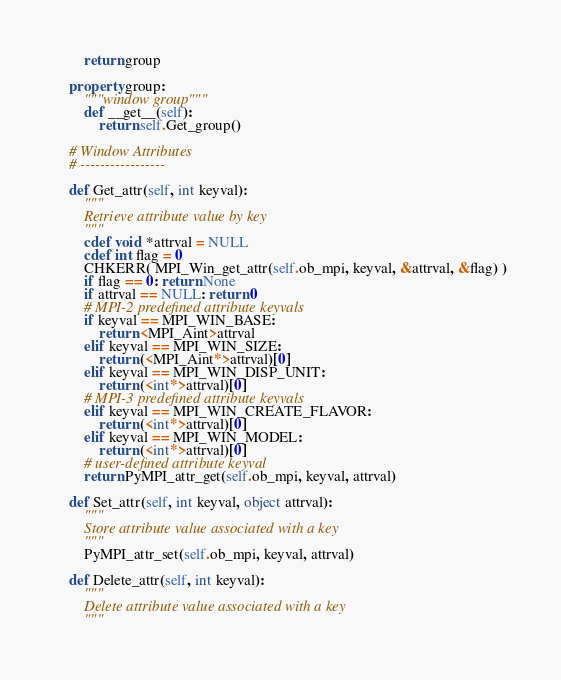Convert code to text. <code><loc_0><loc_0><loc_500><loc_500><_Cython_>        return group

    property group:
        """window group"""
        def __get__(self):
            return self.Get_group()

    # Window Attributes
    # -----------------

    def Get_attr(self, int keyval):
        """
        Retrieve attribute value by key
        """
        cdef void *attrval = NULL
        cdef int flag = 0
        CHKERR( MPI_Win_get_attr(self.ob_mpi, keyval, &attrval, &flag) )
        if flag == 0: return None
        if attrval == NULL: return 0
        # MPI-2 predefined attribute keyvals
        if keyval == MPI_WIN_BASE:
            return <MPI_Aint>attrval
        elif keyval == MPI_WIN_SIZE:
            return (<MPI_Aint*>attrval)[0]
        elif keyval == MPI_WIN_DISP_UNIT:
            return (<int*>attrval)[0]
        # MPI-3 predefined attribute keyvals
        elif keyval == MPI_WIN_CREATE_FLAVOR:
            return (<int*>attrval)[0]
        elif keyval == MPI_WIN_MODEL:
            return (<int*>attrval)[0]
        # user-defined attribute keyval
        return PyMPI_attr_get(self.ob_mpi, keyval, attrval)

    def Set_attr(self, int keyval, object attrval):
        """
        Store attribute value associated with a key
        """
        PyMPI_attr_set(self.ob_mpi, keyval, attrval)

    def Delete_attr(self, int keyval):
        """
        Delete attribute value associated with a key
        """</code> 